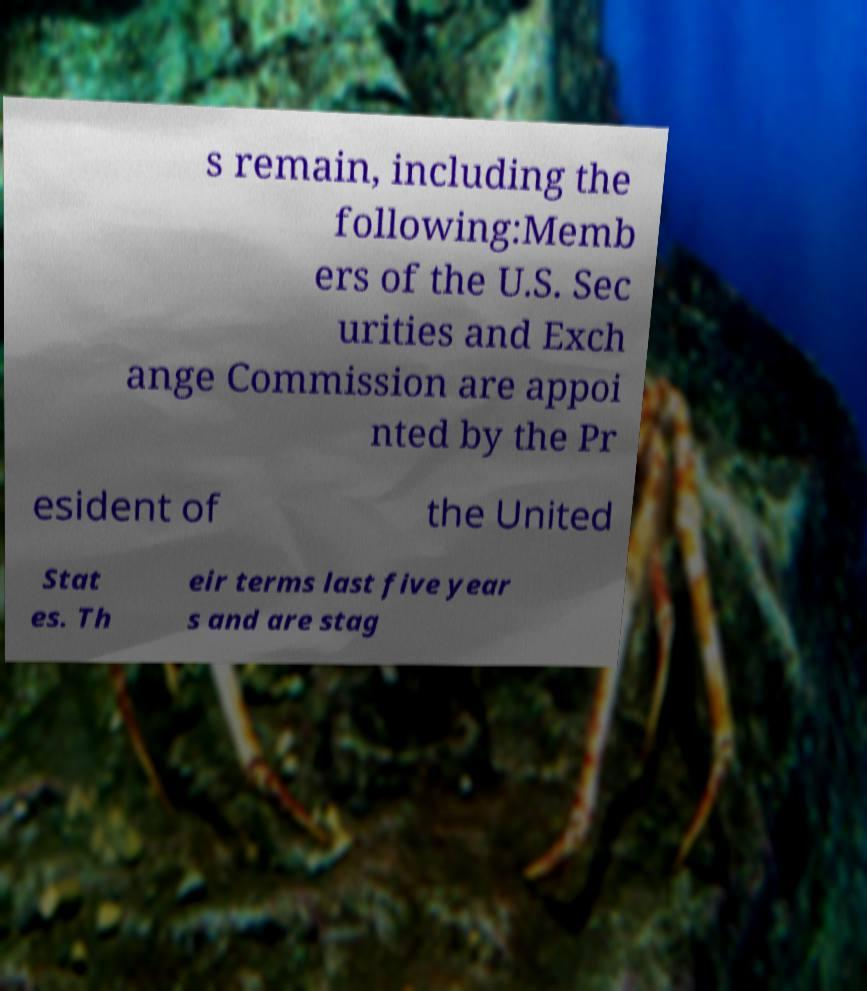Can you accurately transcribe the text from the provided image for me? s remain, including the following:Memb ers of the U.S. Sec urities and Exch ange Commission are appoi nted by the Pr esident of the United Stat es. Th eir terms last five year s and are stag 